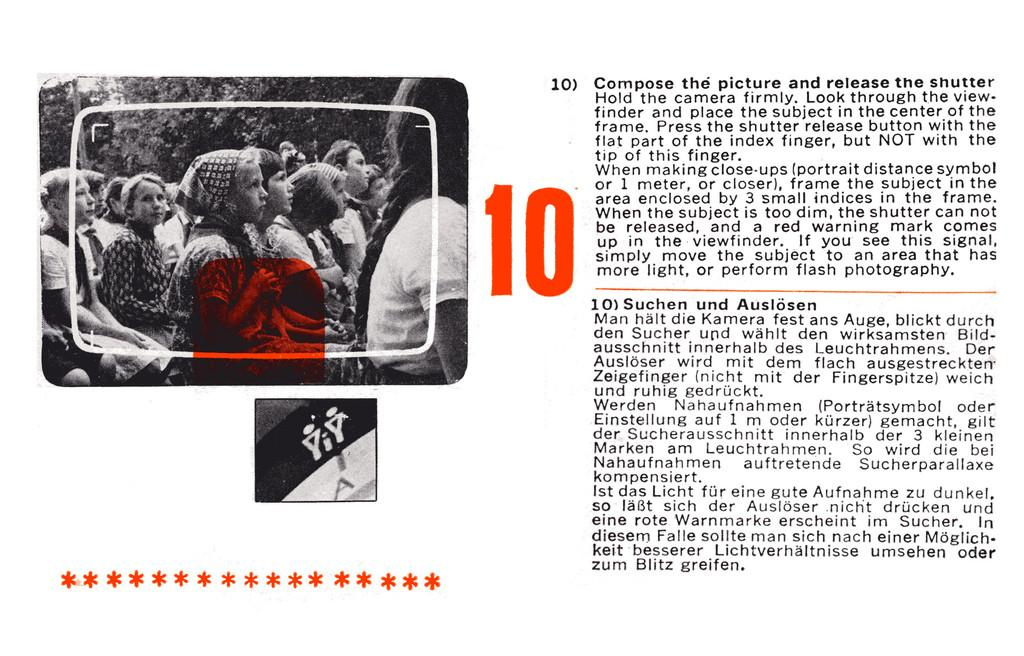What is the color scheme of the image? The image is black and white. How many girls are present in the image? There are multiple girls in the image. What are the girls doing in the image? The girls are sitting on the floor. Where can you find text in the image? There is printed text on the right side of the image. What flavor of ice cream are the girls eating in the image? There is no ice cream present in the image, so it is not possible to determine the flavor. Can you see a pipe in the image? There is no pipe visible in the image. 